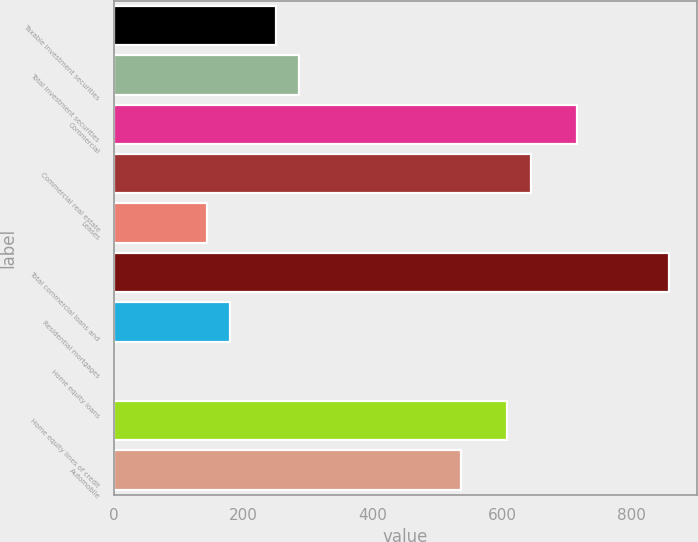<chart> <loc_0><loc_0><loc_500><loc_500><bar_chart><fcel>Taxable investment securities<fcel>Total investment securities<fcel>Commercial<fcel>Commercial real estate<fcel>Leases<fcel>Total commercial loans and<fcel>Residential mortgages<fcel>Home equity loans<fcel>Home equity lines of credit<fcel>Automobile<nl><fcel>250.9<fcel>286.6<fcel>715<fcel>643.6<fcel>143.8<fcel>857.8<fcel>179.5<fcel>1<fcel>607.9<fcel>536.5<nl></chart> 